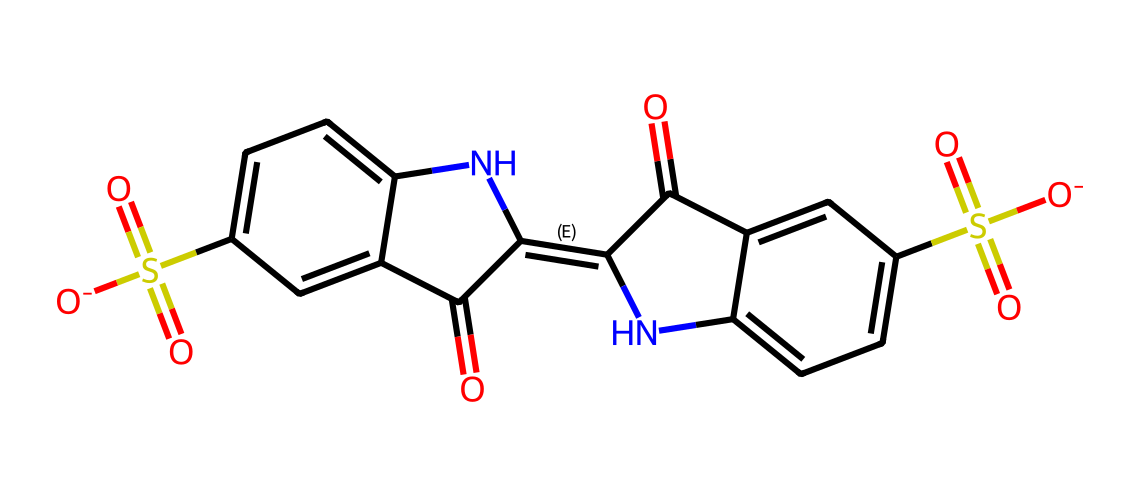What is the molecular formula of indigo carmine? To find the molecular formula, we count the number of each type of atom in the structure from the SMILES. The SMILES representation indicates the presence of 16 carbon atoms, 14 hydrogen atoms, 4 nitrogen atoms, 4 oxygen atoms, and 2 sulfur atoms. Thus, the molecular formula can be deduced from these counts.
Answer: C16H14N2O4S2 How many rings are present in the structure of indigo carmine? By analyzing the chemical structure in the SMILES, we can identify the presence of two fused aromatic rings in the structure. The fusion is indicated by the interconnected carbon atoms that form cycles.
Answer: 2 Is indigo carmine an ionic or covalent compound? Indigo carmine contains both ionic (from the sulfonate groups, evidenced by the negative charges) and covalent bonds (among the carbon and nitrogen atoms in the rings), but the predominant character is covalent due to the extensive interconnected network of carbon atoms.
Answer: covalent What functional groups are present in indigo carmine? In the structure, there are sulfonate groups (indicated by the sulfur and oxygen atoms) and an amine group (indicated by the nitrogen atom attached to carbon). Identifying these groups provides insight into the reactions and properties of indigo carmine.
Answer: sulfonate and amine What property of indigo carmine makes it suitable as a food dye? The presence of large planar conjugated systems, specifically the aromatic rings, allows for significant light absorption in the visible spectrum, hence giving it the ability to impart color. This property is essential for its effectiveness as a dye.
Answer: color absorption 